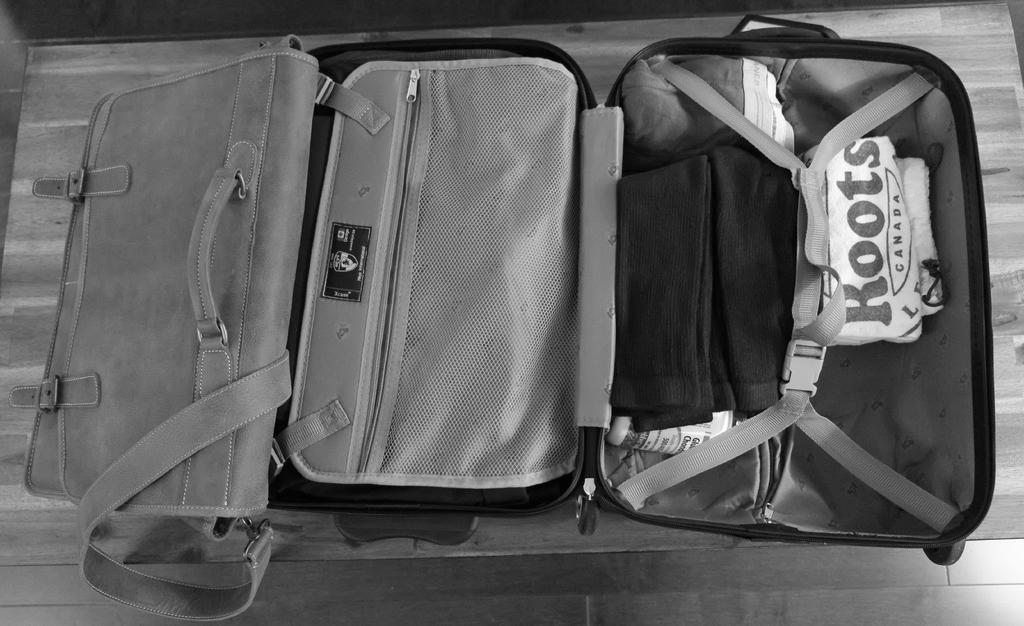Could you give a brief overview of what you see in this image? In this image I see a suitcase in which there are clothes. 